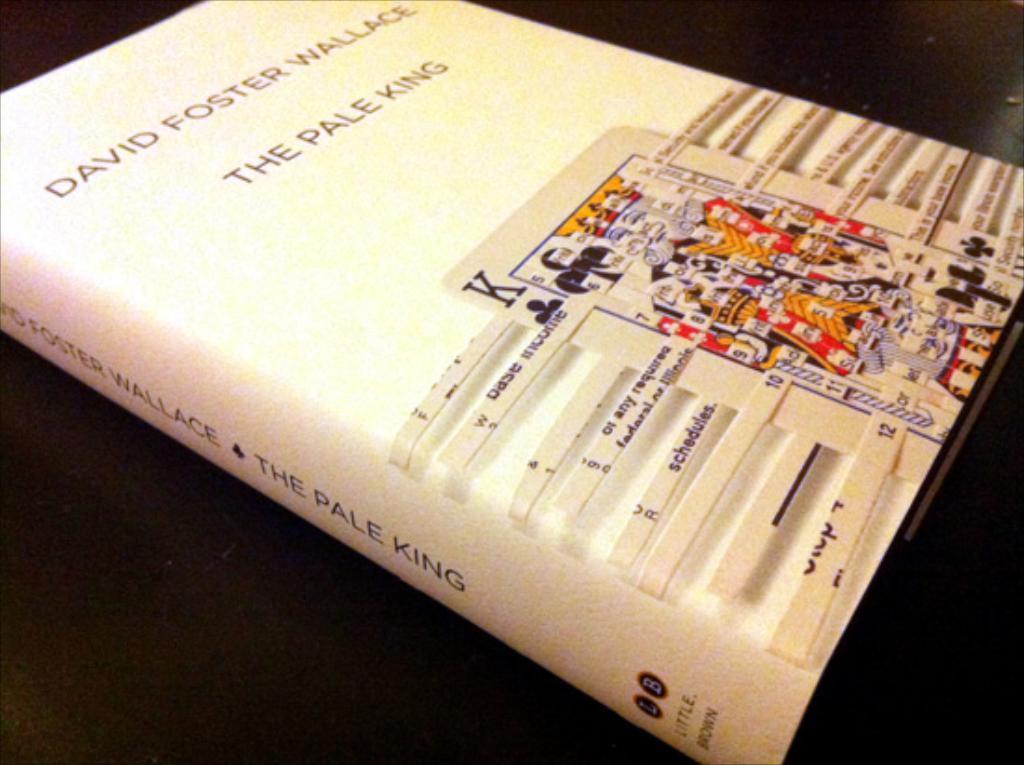What is the title?
Provide a succinct answer. The pale king. 